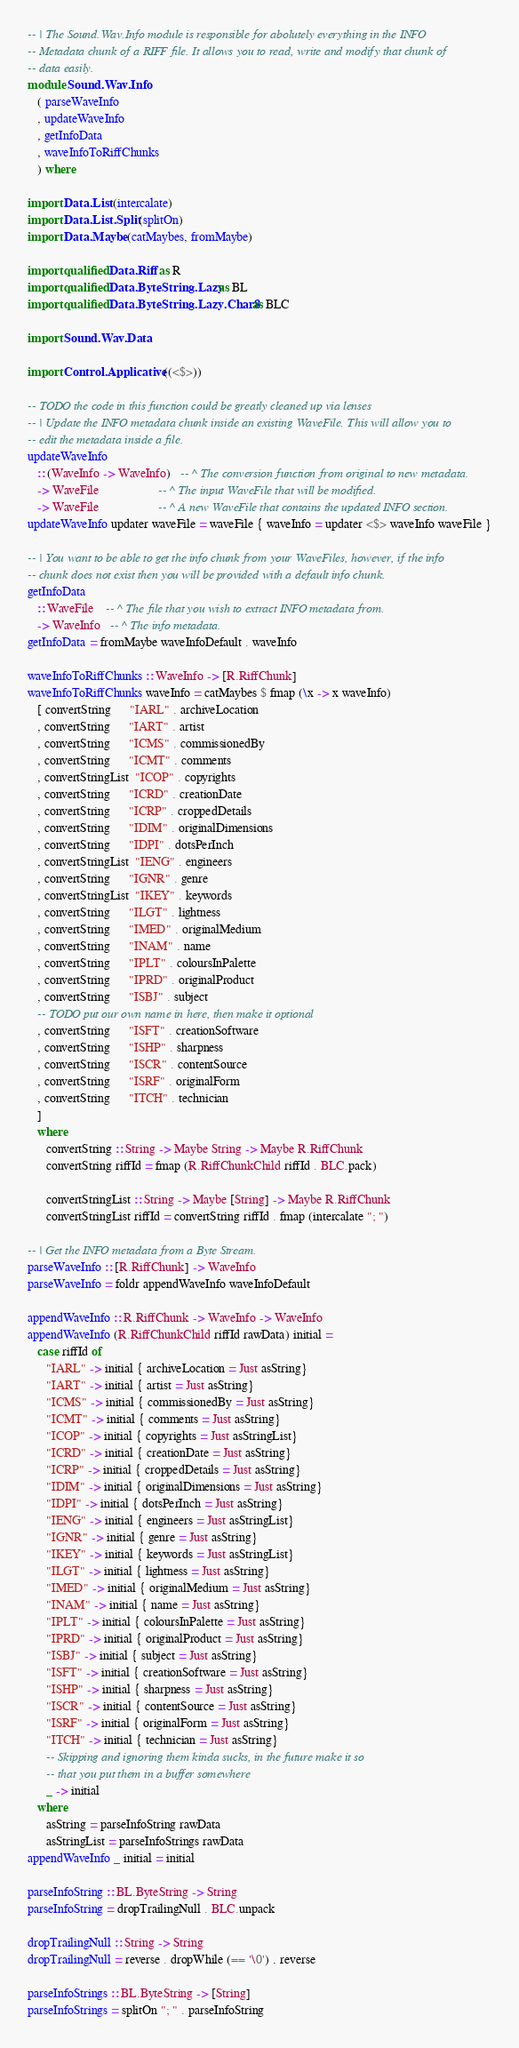Convert code to text. <code><loc_0><loc_0><loc_500><loc_500><_Haskell_>-- | The Sound.Wav.Info module is responsible for abolutely everything in the INFO
-- Metadata chunk of a RIFF file. It allows you to read, write and modify that chunk of
-- data easily.
module Sound.Wav.Info 
   ( parseWaveInfo
   , updateWaveInfo
   , getInfoData
   , waveInfoToRiffChunks
   ) where

import Data.List (intercalate)
import Data.List.Split (splitOn)
import Data.Maybe (catMaybes, fromMaybe)

import qualified Data.Riff as R
import qualified Data.ByteString.Lazy as BL
import qualified Data.ByteString.Lazy.Char8 as BLC

import Sound.Wav.Data

import Control.Applicative ((<$>))

-- TODO the code in this function could be greatly cleaned up via lenses
-- | Update the INFO metadata chunk inside an existing WaveFile. This will allow you to
-- edit the metadata inside a file.
updateWaveInfo 
   :: (WaveInfo -> WaveInfo)   -- ^ The conversion function from original to new metadata.
   -> WaveFile                   -- ^ The input WaveFile that will be modified.
   -> WaveFile                   -- ^ A new WaveFile that contains the updated INFO section.
updateWaveInfo updater waveFile = waveFile { waveInfo = updater <$> waveInfo waveFile }

-- | You want to be able to get the info chunk from your WaveFiles, however, if the info
-- chunk does not exist then you will be provided with a default info chunk.
getInfoData 
   :: WaveFile    -- ^ The file that you wish to extract INFO metadata from.
   -> WaveInfo   -- ^ The info metadata.
getInfoData = fromMaybe waveInfoDefault . waveInfo

waveInfoToRiffChunks :: WaveInfo -> [R.RiffChunk]
waveInfoToRiffChunks waveInfo = catMaybes $ fmap (\x -> x waveInfo)
   [ convertString      "IARL" . archiveLocation
   , convertString      "IART" . artist
   , convertString      "ICMS" . commissionedBy 
   , convertString      "ICMT" . comments
   , convertStringList  "ICOP" . copyrights
   , convertString      "ICRD" . creationDate
   , convertString      "ICRP" . croppedDetails
   , convertString      "IDIM" . originalDimensions
   , convertString      "IDPI" . dotsPerInch
   , convertStringList  "IENG" . engineers
   , convertString      "IGNR" . genre
   , convertStringList  "IKEY" . keywords
   , convertString      "ILGT" . lightness
   , convertString      "IMED" . originalMedium
   , convertString      "INAM" . name
   , convertString      "IPLT" . coloursInPalette
   , convertString      "IPRD" . originalProduct
   , convertString      "ISBJ" . subject
   -- TODO put our own name in here, then make it optional
   , convertString      "ISFT" . creationSoftware
   , convertString      "ISHP" . sharpness
   , convertString      "ISCR" . contentSource
   , convertString      "ISRF" . originalForm
   , convertString      "ITCH" . technician
   ]
   where
      convertString :: String -> Maybe String -> Maybe R.RiffChunk
      convertString riffId = fmap (R.RiffChunkChild riffId . BLC.pack)

      convertStringList :: String -> Maybe [String] -> Maybe R.RiffChunk
      convertStringList riffId = convertString riffId . fmap (intercalate "; ")

-- | Get the INFO metadata from a Byte Stream.
parseWaveInfo :: [R.RiffChunk] -> WaveInfo
parseWaveInfo = foldr appendWaveInfo waveInfoDefault 

appendWaveInfo :: R.RiffChunk -> WaveInfo -> WaveInfo
appendWaveInfo (R.RiffChunkChild riffId rawData) initial =
   case riffId of
      "IARL" -> initial { archiveLocation = Just asString}
      "IART" -> initial { artist = Just asString}
      "ICMS" -> initial { commissionedBy = Just asString}
      "ICMT" -> initial { comments = Just asString}
      "ICOP" -> initial { copyrights = Just asStringList}
      "ICRD" -> initial { creationDate = Just asString}
      "ICRP" -> initial { croppedDetails = Just asString}
      "IDIM" -> initial { originalDimensions = Just asString}
      "IDPI" -> initial { dotsPerInch = Just asString}
      "IENG" -> initial { engineers = Just asStringList}
      "IGNR" -> initial { genre = Just asString}
      "IKEY" -> initial { keywords = Just asStringList}
      "ILGT" -> initial { lightness = Just asString}
      "IMED" -> initial { originalMedium = Just asString}
      "INAM" -> initial { name = Just asString}
      "IPLT" -> initial { coloursInPalette = Just asString}
      "IPRD" -> initial { originalProduct = Just asString}
      "ISBJ" -> initial { subject = Just asString}
      "ISFT" -> initial { creationSoftware = Just asString}
      "ISHP" -> initial { sharpness = Just asString}
      "ISCR" -> initial { contentSource = Just asString}
      "ISRF" -> initial { originalForm = Just asString}
      "ITCH" -> initial { technician = Just asString}
      -- Skipping and ignoring them kinda sucks, in the future make it so 
      -- that you put them in a buffer somewhere
      _ -> initial
   where
      asString = parseInfoString rawData
      asStringList = parseInfoStrings rawData
appendWaveInfo _ initial = initial

parseInfoString :: BL.ByteString -> String
parseInfoString = dropTrailingNull . BLC.unpack

dropTrailingNull :: String -> String
dropTrailingNull = reverse . dropWhile (== '\0') . reverse

parseInfoStrings :: BL.ByteString -> [String]
parseInfoStrings = splitOn "; " . parseInfoString
</code> 